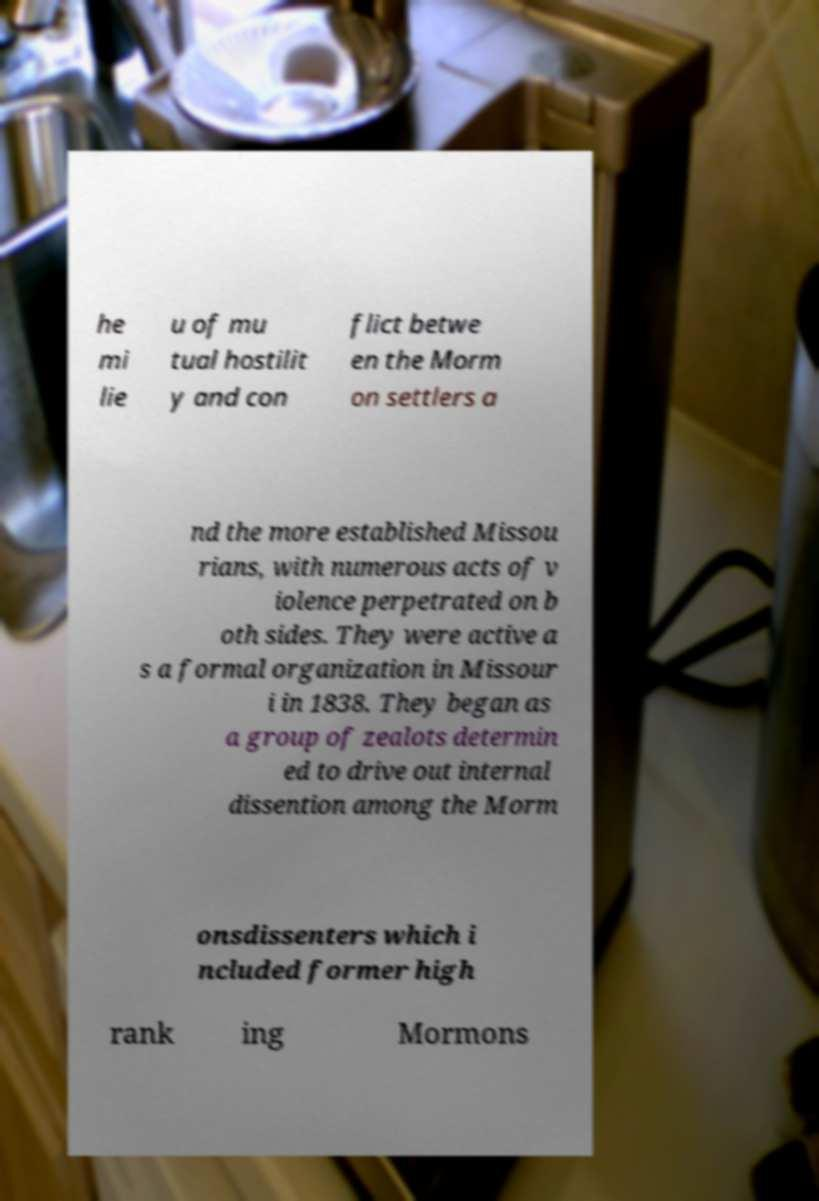Please identify and transcribe the text found in this image. he mi lie u of mu tual hostilit y and con flict betwe en the Morm on settlers a nd the more established Missou rians, with numerous acts of v iolence perpetrated on b oth sides. They were active a s a formal organization in Missour i in 1838. They began as a group of zealots determin ed to drive out internal dissention among the Morm onsdissenters which i ncluded former high rank ing Mormons 